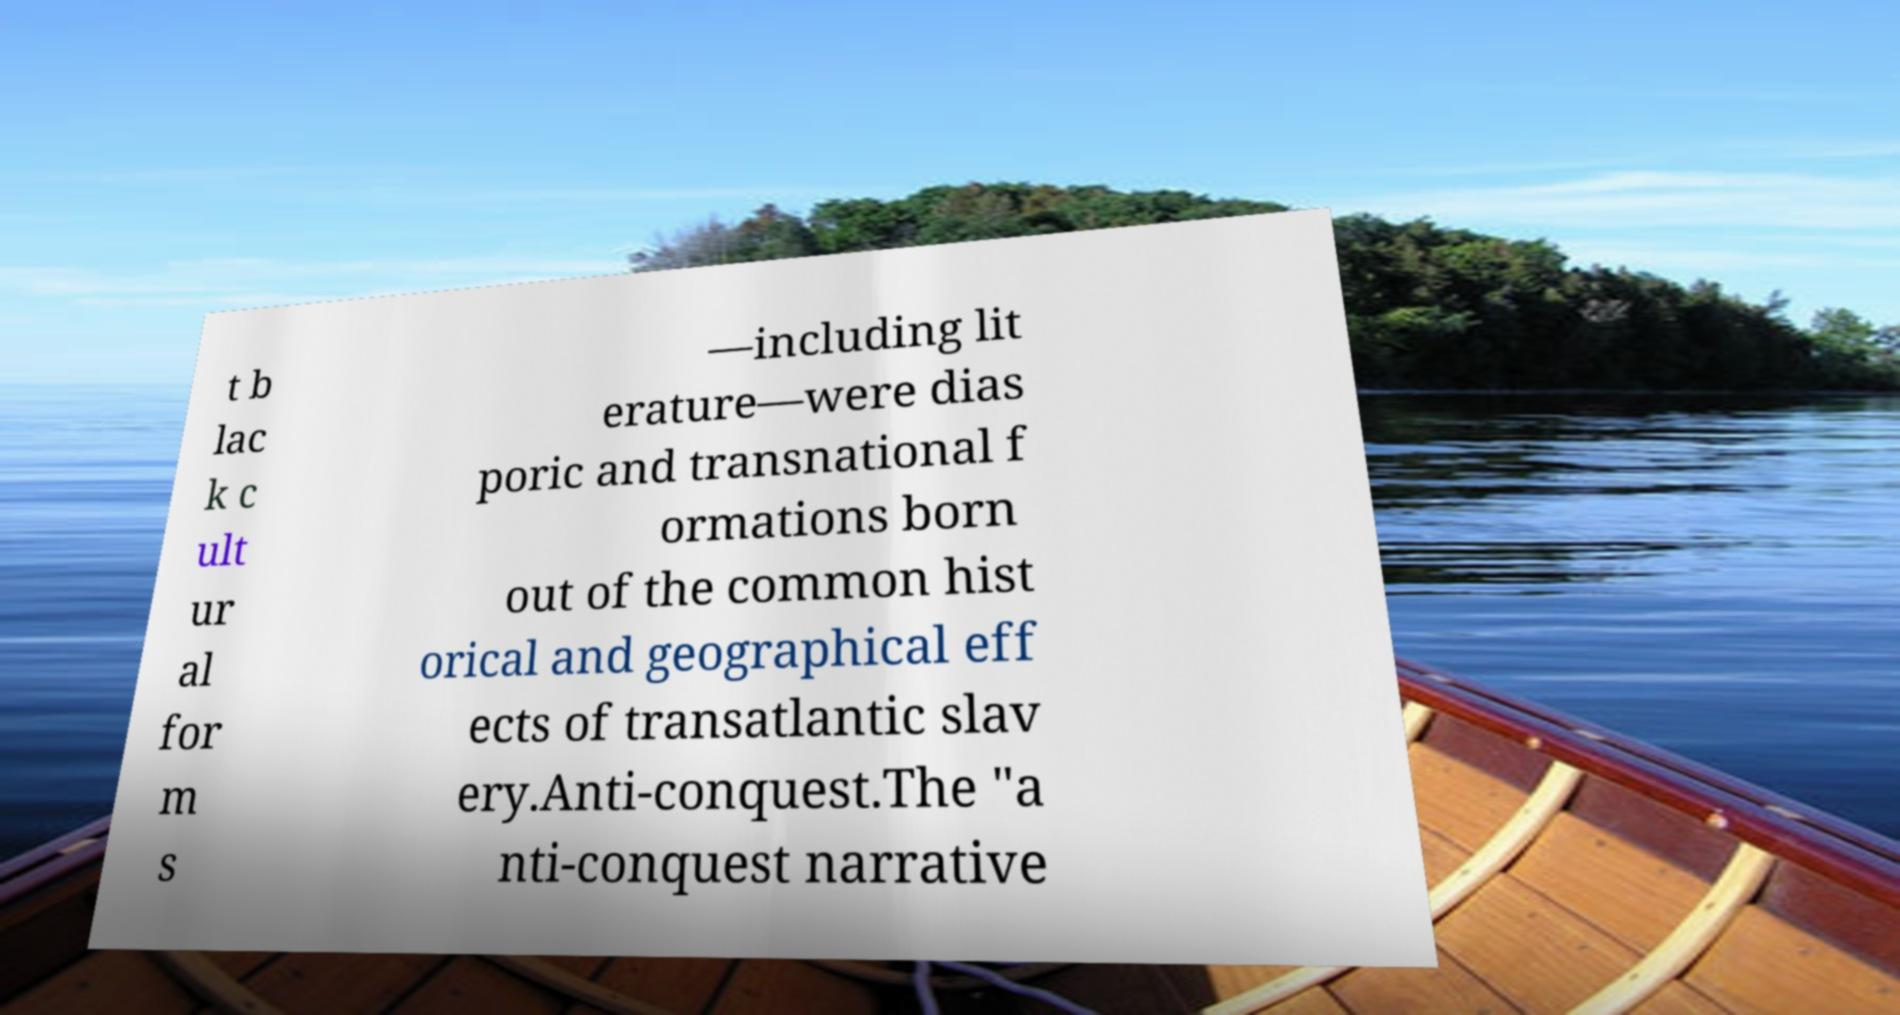Please identify and transcribe the text found in this image. t b lac k c ult ur al for m s —including lit erature—were dias poric and transnational f ormations born out of the common hist orical and geographical eff ects of transatlantic slav ery.Anti-conquest.The "a nti-conquest narrative 